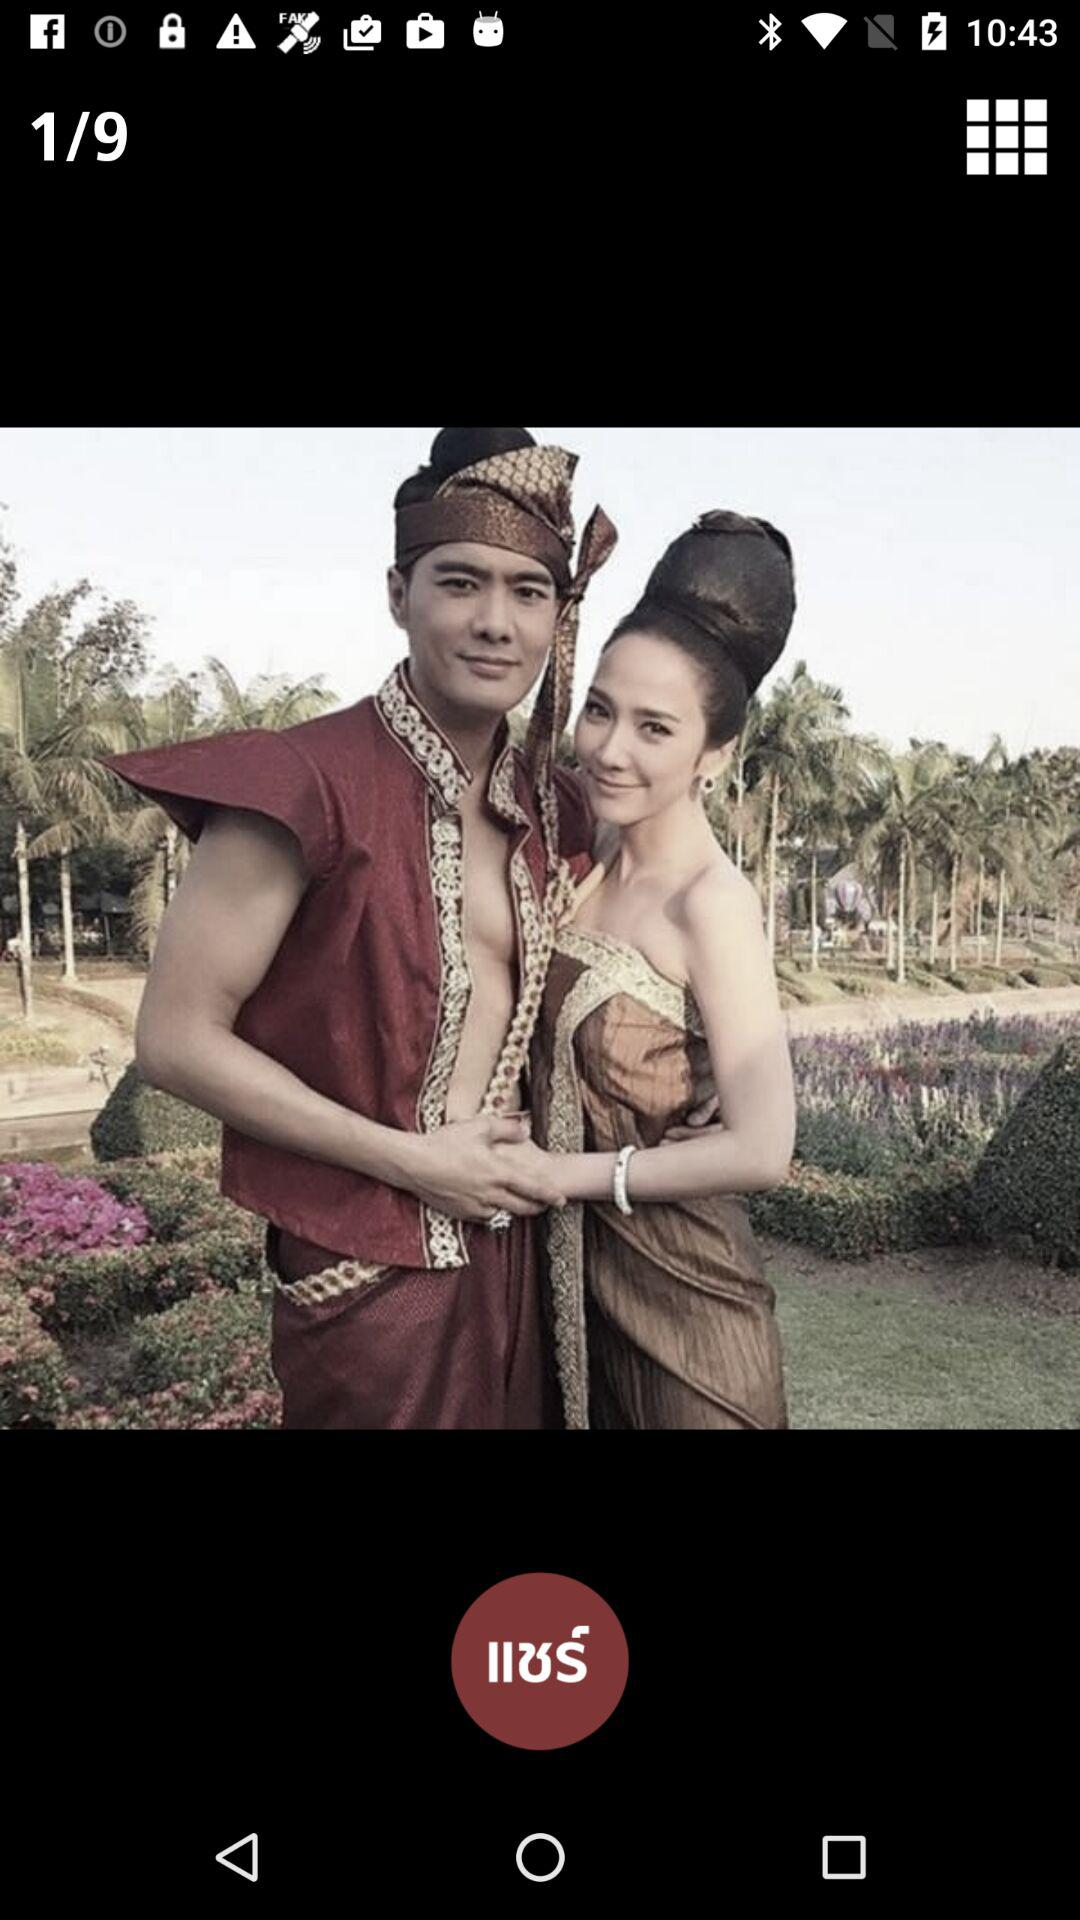How many images in total are given? There are 9 images in total. 